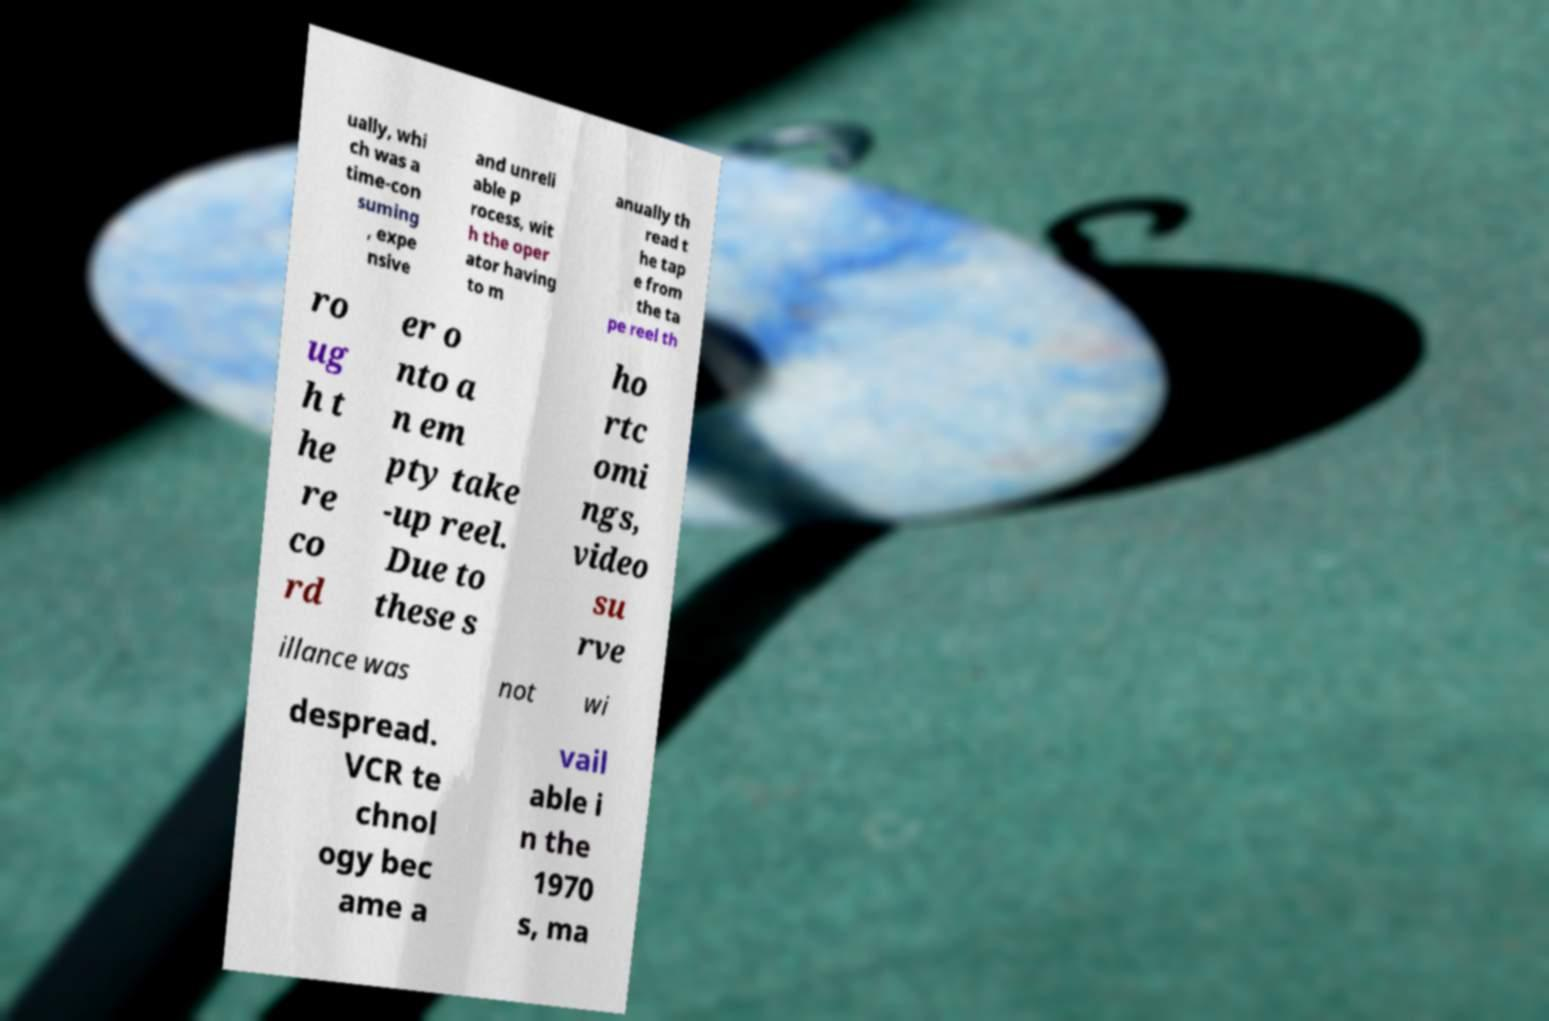Can you accurately transcribe the text from the provided image for me? ually, whi ch was a time-con suming , expe nsive and unreli able p rocess, wit h the oper ator having to m anually th read t he tap e from the ta pe reel th ro ug h t he re co rd er o nto a n em pty take -up reel. Due to these s ho rtc omi ngs, video su rve illance was not wi despread. VCR te chnol ogy bec ame a vail able i n the 1970 s, ma 